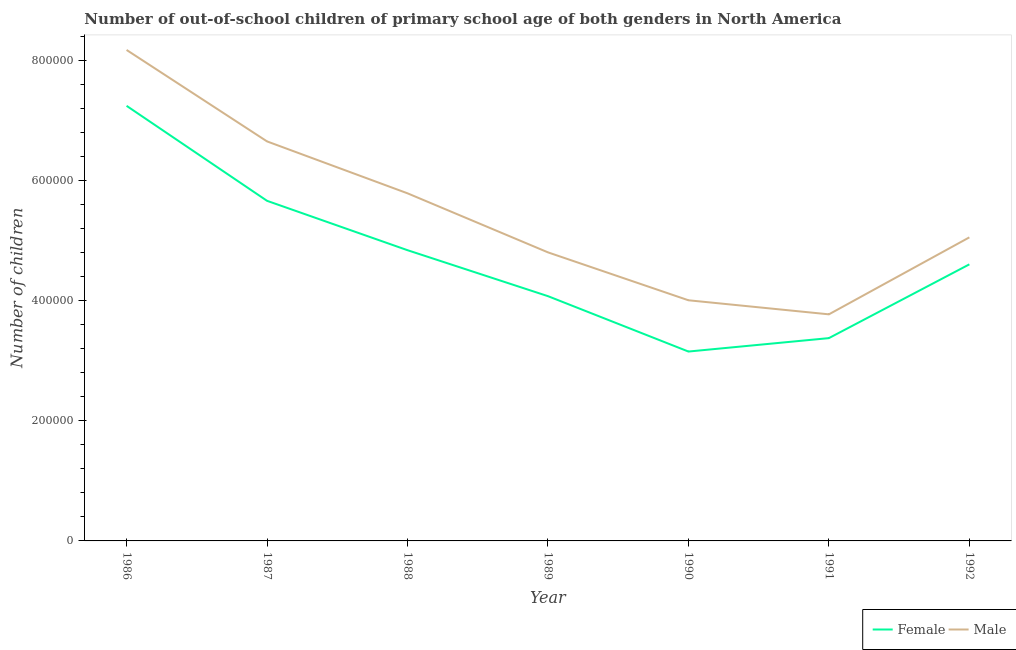How many different coloured lines are there?
Offer a very short reply. 2. Is the number of lines equal to the number of legend labels?
Ensure brevity in your answer.  Yes. What is the number of female out-of-school students in 1989?
Give a very brief answer. 4.07e+05. Across all years, what is the maximum number of male out-of-school students?
Offer a very short reply. 8.17e+05. Across all years, what is the minimum number of female out-of-school students?
Your answer should be compact. 3.15e+05. What is the total number of male out-of-school students in the graph?
Your response must be concise. 3.82e+06. What is the difference between the number of male out-of-school students in 1990 and that in 1992?
Your answer should be compact. -1.05e+05. What is the difference between the number of male out-of-school students in 1989 and the number of female out-of-school students in 1986?
Make the answer very short. -2.44e+05. What is the average number of female out-of-school students per year?
Ensure brevity in your answer.  4.71e+05. In the year 1986, what is the difference between the number of female out-of-school students and number of male out-of-school students?
Provide a succinct answer. -9.30e+04. In how many years, is the number of female out-of-school students greater than 440000?
Provide a succinct answer. 4. What is the ratio of the number of male out-of-school students in 1989 to that in 1991?
Offer a terse response. 1.27. What is the difference between the highest and the second highest number of female out-of-school students?
Your answer should be very brief. 1.58e+05. What is the difference between the highest and the lowest number of male out-of-school students?
Ensure brevity in your answer.  4.40e+05. In how many years, is the number of male out-of-school students greater than the average number of male out-of-school students taken over all years?
Provide a succinct answer. 3. Is the sum of the number of male out-of-school students in 1986 and 1992 greater than the maximum number of female out-of-school students across all years?
Provide a short and direct response. Yes. Is the number of male out-of-school students strictly greater than the number of female out-of-school students over the years?
Make the answer very short. Yes. Is the number of male out-of-school students strictly less than the number of female out-of-school students over the years?
Make the answer very short. No. How many years are there in the graph?
Offer a very short reply. 7. Does the graph contain any zero values?
Your response must be concise. No. Where does the legend appear in the graph?
Offer a terse response. Bottom right. How many legend labels are there?
Your response must be concise. 2. How are the legend labels stacked?
Ensure brevity in your answer.  Horizontal. What is the title of the graph?
Make the answer very short. Number of out-of-school children of primary school age of both genders in North America. What is the label or title of the X-axis?
Your response must be concise. Year. What is the label or title of the Y-axis?
Provide a succinct answer. Number of children. What is the Number of children in Female in 1986?
Offer a terse response. 7.24e+05. What is the Number of children of Male in 1986?
Your response must be concise. 8.17e+05. What is the Number of children in Female in 1987?
Keep it short and to the point. 5.66e+05. What is the Number of children in Male in 1987?
Offer a terse response. 6.65e+05. What is the Number of children in Female in 1988?
Ensure brevity in your answer.  4.84e+05. What is the Number of children in Male in 1988?
Make the answer very short. 5.78e+05. What is the Number of children in Female in 1989?
Offer a terse response. 4.07e+05. What is the Number of children in Male in 1989?
Your answer should be compact. 4.80e+05. What is the Number of children in Female in 1990?
Provide a succinct answer. 3.15e+05. What is the Number of children in Male in 1990?
Provide a succinct answer. 4.00e+05. What is the Number of children of Female in 1991?
Keep it short and to the point. 3.37e+05. What is the Number of children in Male in 1991?
Provide a succinct answer. 3.77e+05. What is the Number of children of Female in 1992?
Your response must be concise. 4.60e+05. What is the Number of children in Male in 1992?
Your response must be concise. 5.05e+05. Across all years, what is the maximum Number of children of Female?
Your response must be concise. 7.24e+05. Across all years, what is the maximum Number of children of Male?
Provide a succinct answer. 8.17e+05. Across all years, what is the minimum Number of children in Female?
Your response must be concise. 3.15e+05. Across all years, what is the minimum Number of children of Male?
Provide a succinct answer. 3.77e+05. What is the total Number of children in Female in the graph?
Make the answer very short. 3.29e+06. What is the total Number of children in Male in the graph?
Provide a succinct answer. 3.82e+06. What is the difference between the Number of children of Female in 1986 and that in 1987?
Provide a succinct answer. 1.58e+05. What is the difference between the Number of children in Male in 1986 and that in 1987?
Your response must be concise. 1.52e+05. What is the difference between the Number of children in Female in 1986 and that in 1988?
Your response must be concise. 2.40e+05. What is the difference between the Number of children in Male in 1986 and that in 1988?
Offer a terse response. 2.39e+05. What is the difference between the Number of children of Female in 1986 and that in 1989?
Offer a terse response. 3.17e+05. What is the difference between the Number of children in Male in 1986 and that in 1989?
Make the answer very short. 3.37e+05. What is the difference between the Number of children of Female in 1986 and that in 1990?
Your answer should be compact. 4.09e+05. What is the difference between the Number of children of Male in 1986 and that in 1990?
Make the answer very short. 4.17e+05. What is the difference between the Number of children of Female in 1986 and that in 1991?
Provide a succinct answer. 3.87e+05. What is the difference between the Number of children of Male in 1986 and that in 1991?
Ensure brevity in your answer.  4.40e+05. What is the difference between the Number of children in Female in 1986 and that in 1992?
Ensure brevity in your answer.  2.64e+05. What is the difference between the Number of children of Male in 1986 and that in 1992?
Your response must be concise. 3.12e+05. What is the difference between the Number of children of Female in 1987 and that in 1988?
Give a very brief answer. 8.22e+04. What is the difference between the Number of children in Male in 1987 and that in 1988?
Keep it short and to the point. 8.64e+04. What is the difference between the Number of children in Female in 1987 and that in 1989?
Offer a very short reply. 1.59e+05. What is the difference between the Number of children of Male in 1987 and that in 1989?
Your answer should be very brief. 1.85e+05. What is the difference between the Number of children in Female in 1987 and that in 1990?
Make the answer very short. 2.51e+05. What is the difference between the Number of children in Male in 1987 and that in 1990?
Ensure brevity in your answer.  2.64e+05. What is the difference between the Number of children in Female in 1987 and that in 1991?
Give a very brief answer. 2.28e+05. What is the difference between the Number of children in Male in 1987 and that in 1991?
Offer a terse response. 2.88e+05. What is the difference between the Number of children of Female in 1987 and that in 1992?
Provide a short and direct response. 1.06e+05. What is the difference between the Number of children in Male in 1987 and that in 1992?
Your answer should be compact. 1.60e+05. What is the difference between the Number of children of Female in 1988 and that in 1989?
Provide a short and direct response. 7.65e+04. What is the difference between the Number of children in Male in 1988 and that in 1989?
Provide a short and direct response. 9.83e+04. What is the difference between the Number of children of Female in 1988 and that in 1990?
Provide a short and direct response. 1.69e+05. What is the difference between the Number of children in Male in 1988 and that in 1990?
Give a very brief answer. 1.78e+05. What is the difference between the Number of children of Female in 1988 and that in 1991?
Make the answer very short. 1.46e+05. What is the difference between the Number of children in Male in 1988 and that in 1991?
Your answer should be compact. 2.01e+05. What is the difference between the Number of children of Female in 1988 and that in 1992?
Give a very brief answer. 2.36e+04. What is the difference between the Number of children in Male in 1988 and that in 1992?
Offer a very short reply. 7.33e+04. What is the difference between the Number of children of Female in 1989 and that in 1990?
Provide a short and direct response. 9.22e+04. What is the difference between the Number of children of Male in 1989 and that in 1990?
Your answer should be compact. 7.97e+04. What is the difference between the Number of children of Female in 1989 and that in 1991?
Make the answer very short. 6.98e+04. What is the difference between the Number of children in Male in 1989 and that in 1991?
Your answer should be very brief. 1.03e+05. What is the difference between the Number of children in Female in 1989 and that in 1992?
Ensure brevity in your answer.  -5.29e+04. What is the difference between the Number of children of Male in 1989 and that in 1992?
Ensure brevity in your answer.  -2.50e+04. What is the difference between the Number of children in Female in 1990 and that in 1991?
Your response must be concise. -2.23e+04. What is the difference between the Number of children of Male in 1990 and that in 1991?
Your answer should be compact. 2.34e+04. What is the difference between the Number of children of Female in 1990 and that in 1992?
Offer a terse response. -1.45e+05. What is the difference between the Number of children of Male in 1990 and that in 1992?
Ensure brevity in your answer.  -1.05e+05. What is the difference between the Number of children in Female in 1991 and that in 1992?
Provide a short and direct response. -1.23e+05. What is the difference between the Number of children in Male in 1991 and that in 1992?
Provide a short and direct response. -1.28e+05. What is the difference between the Number of children in Female in 1986 and the Number of children in Male in 1987?
Keep it short and to the point. 5.92e+04. What is the difference between the Number of children of Female in 1986 and the Number of children of Male in 1988?
Your answer should be very brief. 1.46e+05. What is the difference between the Number of children in Female in 1986 and the Number of children in Male in 1989?
Make the answer very short. 2.44e+05. What is the difference between the Number of children in Female in 1986 and the Number of children in Male in 1990?
Your response must be concise. 3.24e+05. What is the difference between the Number of children in Female in 1986 and the Number of children in Male in 1991?
Give a very brief answer. 3.47e+05. What is the difference between the Number of children of Female in 1986 and the Number of children of Male in 1992?
Your response must be concise. 2.19e+05. What is the difference between the Number of children of Female in 1987 and the Number of children of Male in 1988?
Your answer should be compact. -1.25e+04. What is the difference between the Number of children of Female in 1987 and the Number of children of Male in 1989?
Provide a succinct answer. 8.58e+04. What is the difference between the Number of children of Female in 1987 and the Number of children of Male in 1990?
Your answer should be compact. 1.66e+05. What is the difference between the Number of children in Female in 1987 and the Number of children in Male in 1991?
Offer a terse response. 1.89e+05. What is the difference between the Number of children of Female in 1987 and the Number of children of Male in 1992?
Provide a short and direct response. 6.08e+04. What is the difference between the Number of children in Female in 1988 and the Number of children in Male in 1989?
Keep it short and to the point. 3613. What is the difference between the Number of children of Female in 1988 and the Number of children of Male in 1990?
Your answer should be very brief. 8.33e+04. What is the difference between the Number of children of Female in 1988 and the Number of children of Male in 1991?
Keep it short and to the point. 1.07e+05. What is the difference between the Number of children in Female in 1988 and the Number of children in Male in 1992?
Your answer should be compact. -2.14e+04. What is the difference between the Number of children in Female in 1989 and the Number of children in Male in 1990?
Offer a very short reply. 6836. What is the difference between the Number of children of Female in 1989 and the Number of children of Male in 1991?
Provide a succinct answer. 3.02e+04. What is the difference between the Number of children in Female in 1989 and the Number of children in Male in 1992?
Your answer should be compact. -9.79e+04. What is the difference between the Number of children in Female in 1990 and the Number of children in Male in 1991?
Provide a short and direct response. -6.19e+04. What is the difference between the Number of children in Female in 1990 and the Number of children in Male in 1992?
Give a very brief answer. -1.90e+05. What is the difference between the Number of children of Female in 1991 and the Number of children of Male in 1992?
Provide a succinct answer. -1.68e+05. What is the average Number of children in Female per year?
Provide a short and direct response. 4.71e+05. What is the average Number of children of Male per year?
Ensure brevity in your answer.  5.46e+05. In the year 1986, what is the difference between the Number of children of Female and Number of children of Male?
Offer a terse response. -9.30e+04. In the year 1987, what is the difference between the Number of children in Female and Number of children in Male?
Provide a short and direct response. -9.89e+04. In the year 1988, what is the difference between the Number of children in Female and Number of children in Male?
Your answer should be very brief. -9.47e+04. In the year 1989, what is the difference between the Number of children of Female and Number of children of Male?
Make the answer very short. -7.29e+04. In the year 1990, what is the difference between the Number of children in Female and Number of children in Male?
Offer a very short reply. -8.53e+04. In the year 1991, what is the difference between the Number of children in Female and Number of children in Male?
Make the answer very short. -3.96e+04. In the year 1992, what is the difference between the Number of children of Female and Number of children of Male?
Keep it short and to the point. -4.49e+04. What is the ratio of the Number of children in Female in 1986 to that in 1987?
Provide a succinct answer. 1.28. What is the ratio of the Number of children in Male in 1986 to that in 1987?
Ensure brevity in your answer.  1.23. What is the ratio of the Number of children in Female in 1986 to that in 1988?
Keep it short and to the point. 1.5. What is the ratio of the Number of children in Male in 1986 to that in 1988?
Give a very brief answer. 1.41. What is the ratio of the Number of children of Female in 1986 to that in 1989?
Your answer should be compact. 1.78. What is the ratio of the Number of children of Male in 1986 to that in 1989?
Your answer should be very brief. 1.7. What is the ratio of the Number of children in Female in 1986 to that in 1990?
Ensure brevity in your answer.  2.3. What is the ratio of the Number of children in Male in 1986 to that in 1990?
Provide a short and direct response. 2.04. What is the ratio of the Number of children in Female in 1986 to that in 1991?
Your response must be concise. 2.15. What is the ratio of the Number of children of Male in 1986 to that in 1991?
Your answer should be very brief. 2.17. What is the ratio of the Number of children in Female in 1986 to that in 1992?
Your response must be concise. 1.57. What is the ratio of the Number of children in Male in 1986 to that in 1992?
Keep it short and to the point. 1.62. What is the ratio of the Number of children in Female in 1987 to that in 1988?
Make the answer very short. 1.17. What is the ratio of the Number of children in Male in 1987 to that in 1988?
Offer a terse response. 1.15. What is the ratio of the Number of children in Female in 1987 to that in 1989?
Keep it short and to the point. 1.39. What is the ratio of the Number of children of Male in 1987 to that in 1989?
Your answer should be compact. 1.38. What is the ratio of the Number of children in Female in 1987 to that in 1990?
Provide a short and direct response. 1.8. What is the ratio of the Number of children in Male in 1987 to that in 1990?
Ensure brevity in your answer.  1.66. What is the ratio of the Number of children of Female in 1987 to that in 1991?
Provide a succinct answer. 1.68. What is the ratio of the Number of children in Male in 1987 to that in 1991?
Keep it short and to the point. 1.76. What is the ratio of the Number of children in Female in 1987 to that in 1992?
Offer a terse response. 1.23. What is the ratio of the Number of children in Male in 1987 to that in 1992?
Your answer should be compact. 1.32. What is the ratio of the Number of children of Female in 1988 to that in 1989?
Offer a terse response. 1.19. What is the ratio of the Number of children of Male in 1988 to that in 1989?
Make the answer very short. 1.2. What is the ratio of the Number of children of Female in 1988 to that in 1990?
Your response must be concise. 1.54. What is the ratio of the Number of children in Male in 1988 to that in 1990?
Offer a terse response. 1.44. What is the ratio of the Number of children of Female in 1988 to that in 1991?
Keep it short and to the point. 1.43. What is the ratio of the Number of children in Male in 1988 to that in 1991?
Your answer should be compact. 1.53. What is the ratio of the Number of children of Female in 1988 to that in 1992?
Your answer should be very brief. 1.05. What is the ratio of the Number of children of Male in 1988 to that in 1992?
Your answer should be very brief. 1.15. What is the ratio of the Number of children of Female in 1989 to that in 1990?
Ensure brevity in your answer.  1.29. What is the ratio of the Number of children in Male in 1989 to that in 1990?
Offer a very short reply. 1.2. What is the ratio of the Number of children of Female in 1989 to that in 1991?
Your answer should be very brief. 1.21. What is the ratio of the Number of children of Male in 1989 to that in 1991?
Your answer should be compact. 1.27. What is the ratio of the Number of children of Female in 1989 to that in 1992?
Your response must be concise. 0.89. What is the ratio of the Number of children in Male in 1989 to that in 1992?
Give a very brief answer. 0.95. What is the ratio of the Number of children of Female in 1990 to that in 1991?
Give a very brief answer. 0.93. What is the ratio of the Number of children of Male in 1990 to that in 1991?
Ensure brevity in your answer.  1.06. What is the ratio of the Number of children of Female in 1990 to that in 1992?
Your answer should be compact. 0.68. What is the ratio of the Number of children in Male in 1990 to that in 1992?
Provide a short and direct response. 0.79. What is the ratio of the Number of children of Female in 1991 to that in 1992?
Give a very brief answer. 0.73. What is the ratio of the Number of children in Male in 1991 to that in 1992?
Your response must be concise. 0.75. What is the difference between the highest and the second highest Number of children of Female?
Offer a terse response. 1.58e+05. What is the difference between the highest and the second highest Number of children in Male?
Offer a very short reply. 1.52e+05. What is the difference between the highest and the lowest Number of children of Female?
Offer a very short reply. 4.09e+05. What is the difference between the highest and the lowest Number of children in Male?
Your response must be concise. 4.40e+05. 